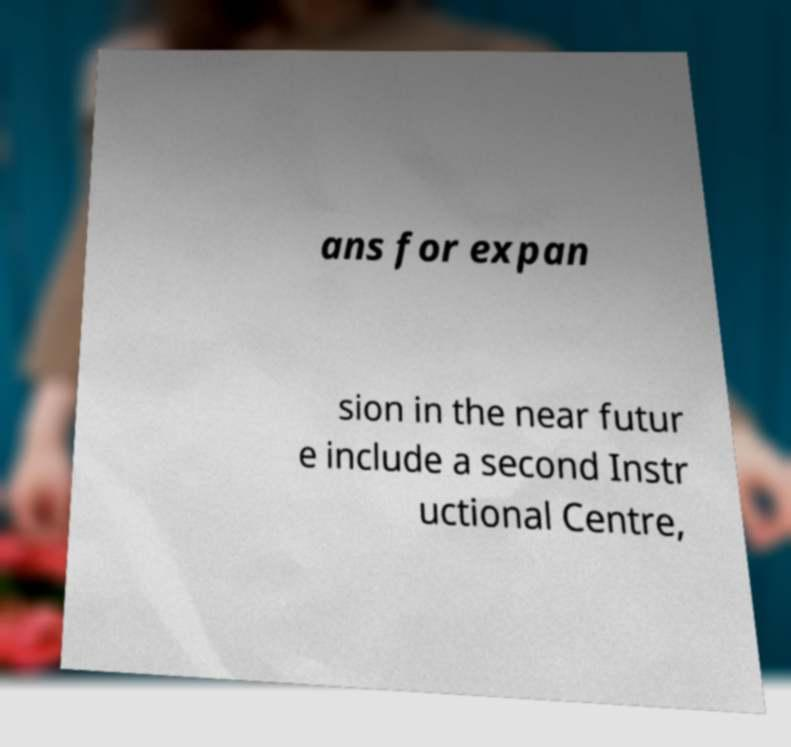Can you accurately transcribe the text from the provided image for me? ans for expan sion in the near futur e include a second Instr uctional Centre, 